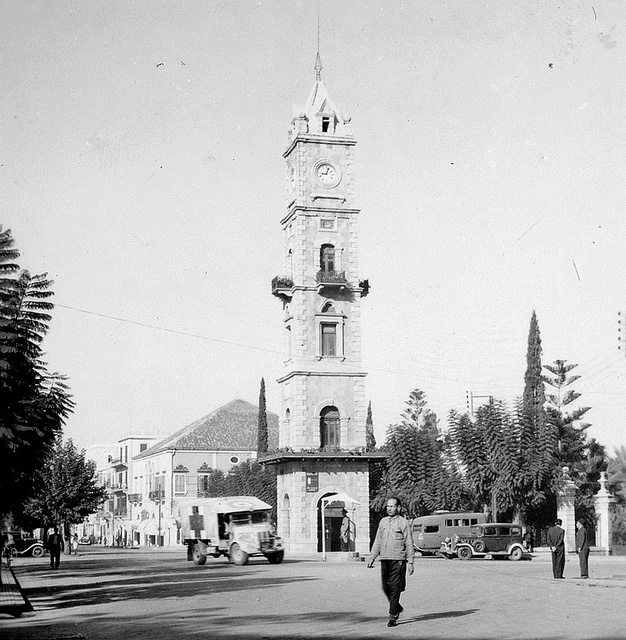Describe the objects in this image and their specific colors. I can see truck in silver, lightgray, black, darkgray, and gray tones, people in silver, darkgray, black, gray, and lightgray tones, truck in silver, black, gray, darkgray, and gainsboro tones, car in silver, black, gray, darkgray, and lightgray tones, and people in silver, black, gray, darkgray, and lightgray tones in this image. 